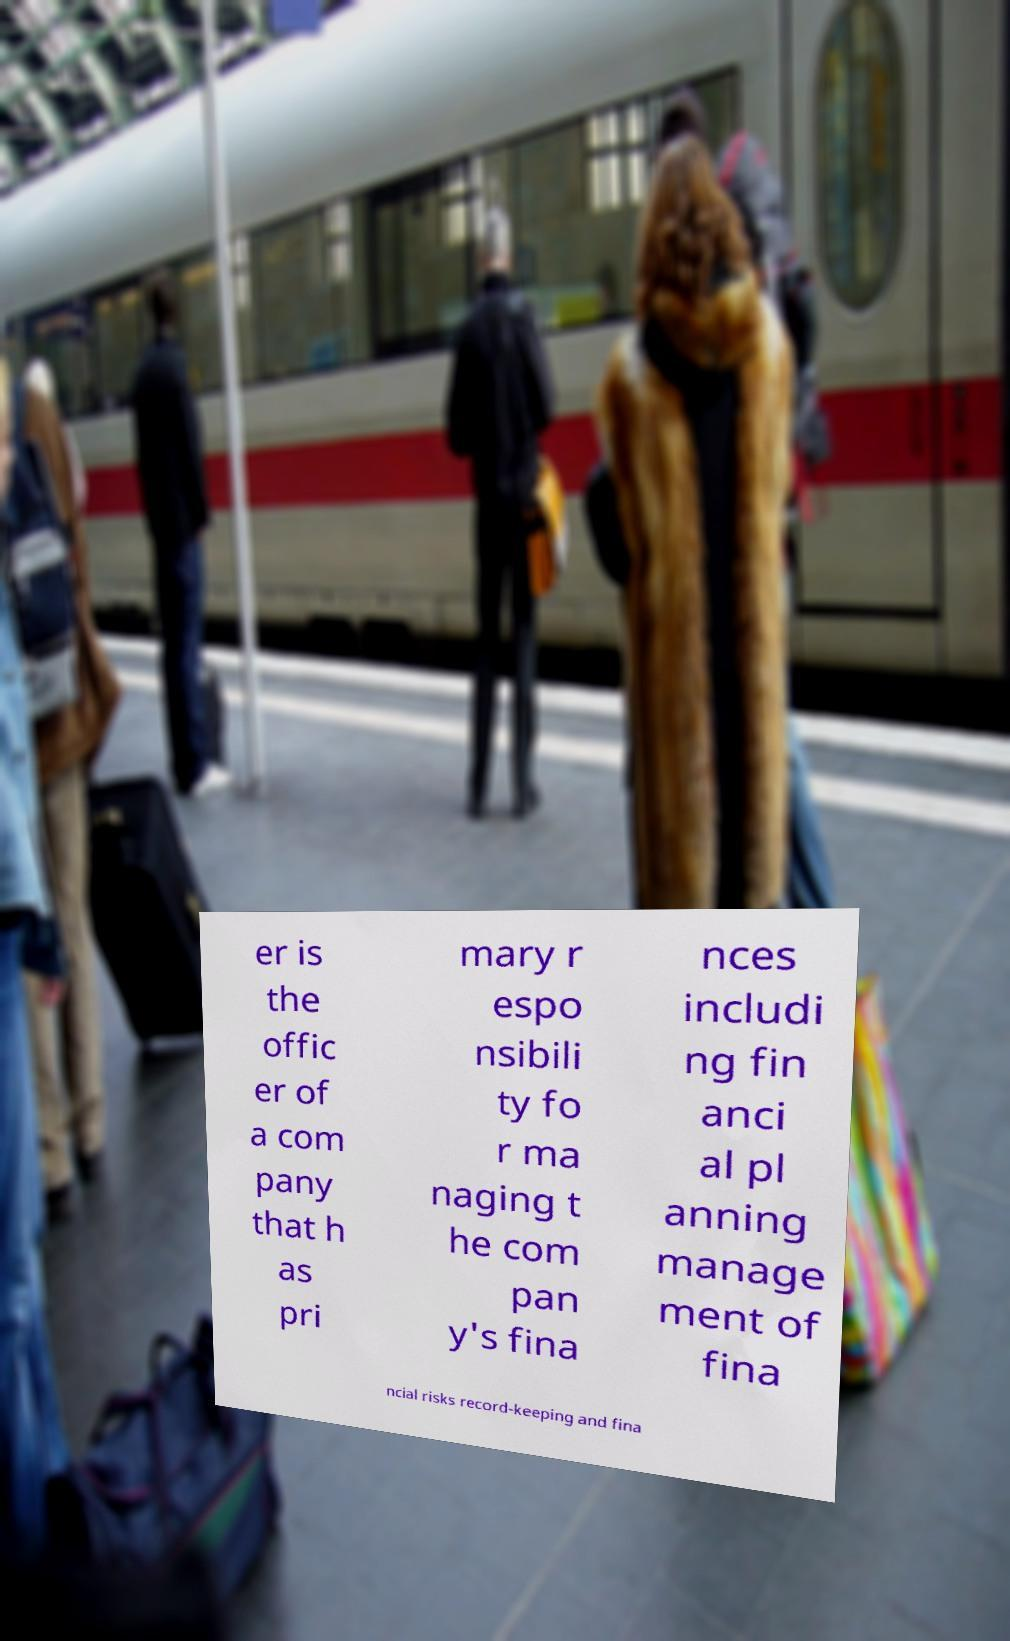Please read and relay the text visible in this image. What does it say? er is the offic er of a com pany that h as pri mary r espo nsibili ty fo r ma naging t he com pan y's fina nces includi ng fin anci al pl anning manage ment of fina ncial risks record-keeping and fina 